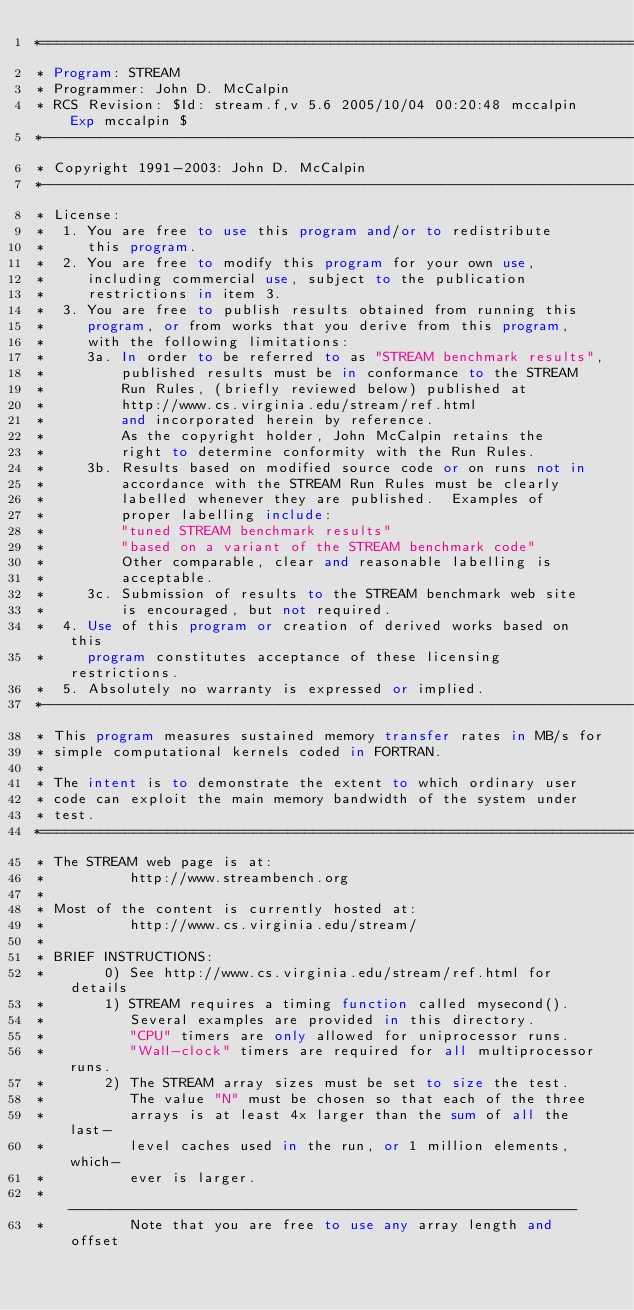<code> <loc_0><loc_0><loc_500><loc_500><_FORTRAN_>*=======================================================================
* Program: STREAM
* Programmer: John D. McCalpin
* RCS Revision: $Id: stream.f,v 5.6 2005/10/04 00:20:48 mccalpin Exp mccalpin $
*-----------------------------------------------------------------------
* Copyright 1991-2003: John D. McCalpin
*-----------------------------------------------------------------------
* License:
*  1. You are free to use this program and/or to redistribute
*     this program.
*  2. You are free to modify this program for your own use,
*     including commercial use, subject to the publication
*     restrictions in item 3.
*  3. You are free to publish results obtained from running this
*     program, or from works that you derive from this program,
*     with the following limitations:
*     3a. In order to be referred to as "STREAM benchmark results",
*         published results must be in conformance to the STREAM
*         Run Rules, (briefly reviewed below) published at
*         http://www.cs.virginia.edu/stream/ref.html
*         and incorporated herein by reference.
*         As the copyright holder, John McCalpin retains the
*         right to determine conformity with the Run Rules.
*     3b. Results based on modified source code or on runs not in
*         accordance with the STREAM Run Rules must be clearly
*         labelled whenever they are published.  Examples of
*         proper labelling include:
*         "tuned STREAM benchmark results" 
*         "based on a variant of the STREAM benchmark code"
*         Other comparable, clear and reasonable labelling is
*         acceptable.
*     3c. Submission of results to the STREAM benchmark web site
*         is encouraged, but not required.
*  4. Use of this program or creation of derived works based on this
*     program constitutes acceptance of these licensing restrictions.
*  5. Absolutely no warranty is expressed or implied.
*-----------------------------------------------------------------------
* This program measures sustained memory transfer rates in MB/s for
* simple computational kernels coded in FORTRAN.
*
* The intent is to demonstrate the extent to which ordinary user
* code can exploit the main memory bandwidth of the system under
* test.
*=======================================================================
* The STREAM web page is at:
*          http://www.streambench.org
*
* Most of the content is currently hosted at:
*          http://www.cs.virginia.edu/stream/
*
* BRIEF INSTRUCTIONS: 
*       0) See http://www.cs.virginia.edu/stream/ref.html for details
*       1) STREAM requires a timing function called mysecond().
*          Several examples are provided in this directory.
*          "CPU" timers are only allowed for uniprocessor runs.
*          "Wall-clock" timers are required for all multiprocessor runs.
*       2) The STREAM array sizes must be set to size the test.
*          The value "N" must be chosen so that each of the three
*          arrays is at least 4x larger than the sum of all the last-
*          level caches used in the run, or 1 million elements, which-
*          ever is larger.
*          ------------------------------------------------------------
*          Note that you are free to use any array length and offset</code> 